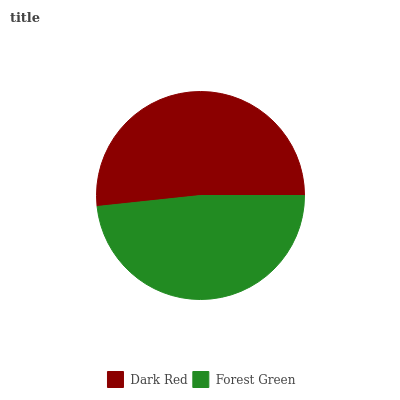Is Forest Green the minimum?
Answer yes or no. Yes. Is Dark Red the maximum?
Answer yes or no. Yes. Is Forest Green the maximum?
Answer yes or no. No. Is Dark Red greater than Forest Green?
Answer yes or no. Yes. Is Forest Green less than Dark Red?
Answer yes or no. Yes. Is Forest Green greater than Dark Red?
Answer yes or no. No. Is Dark Red less than Forest Green?
Answer yes or no. No. Is Dark Red the high median?
Answer yes or no. Yes. Is Forest Green the low median?
Answer yes or no. Yes. Is Forest Green the high median?
Answer yes or no. No. Is Dark Red the low median?
Answer yes or no. No. 